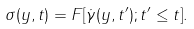Convert formula to latex. <formula><loc_0><loc_0><loc_500><loc_500>\sigma ( y , t ) = F [ \dot { \gamma } ( y , t ^ { \prime } ) ; t ^ { \prime } \leq t ] .</formula> 